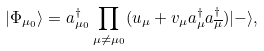Convert formula to latex. <formula><loc_0><loc_0><loc_500><loc_500>| \Phi _ { \mu _ { 0 } } \rangle = a ^ { \dagger } _ { \mu _ { 0 } } \prod _ { \mu \neq \mu _ { 0 } } ( u _ { \mu } + v _ { \mu } a _ { \mu } ^ { \dagger } a _ { \overline { \mu } } ^ { \dagger } ) | - \rangle ,</formula> 